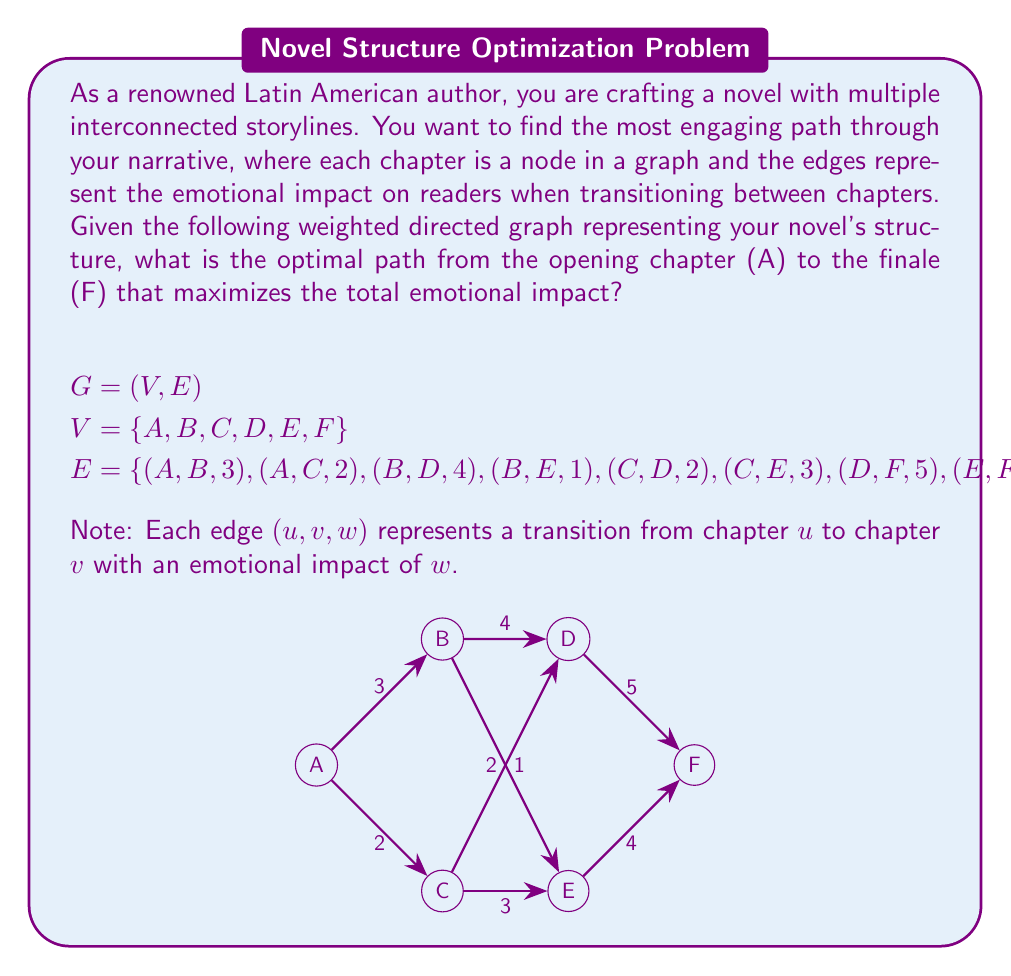Show me your answer to this math problem. To find the optimal path that maximizes the total emotional impact, we need to use Dijkstra's algorithm for the longest path in a Directed Acyclic Graph (DAG). Since we want to maximize the impact, we'll use the negative of the edge weights and find the shortest path.

Step 1: Topologically sort the vertices.
Topological order: A, B, C, D, E, F

Step 2: Initialize distances.
$d[A] = 0$, $d[B] = d[C] = d[D] = d[E] = d[F] = -\infty$

Step 3: Relax edges in topological order.

For vertex A:
$d[B] = \max(d[B], d[A] + 3) = 3$
$d[C] = \max(d[C], d[A] + 2) = 2$

For vertex B:
$d[D] = \max(d[D], d[B] + 4) = 7$
$d[E] = \max(d[E], d[B] + 1) = 4$

For vertex C:
$d[D] = \max(d[D], d[C] + 2) = 7$ (no change)
$d[E] = \max(d[E], d[C] + 3) = 5$

For vertex D:
$d[F] = \max(d[F], d[D] + 5) = 12$

For vertex E:
$d[F] = \max(d[F], d[E] + 4) = 12$ (no change)

Step 4: Backtrack to find the path.
Starting from F, we backtrack to D (12 - 5 = 7), then to B (7 - 4 = 3), and finally to A.

Therefore, the optimal path is A → B → D → F, with a total emotional impact of 12.
Answer: The optimal path is A → B → D → F, with a total emotional impact of 12. 